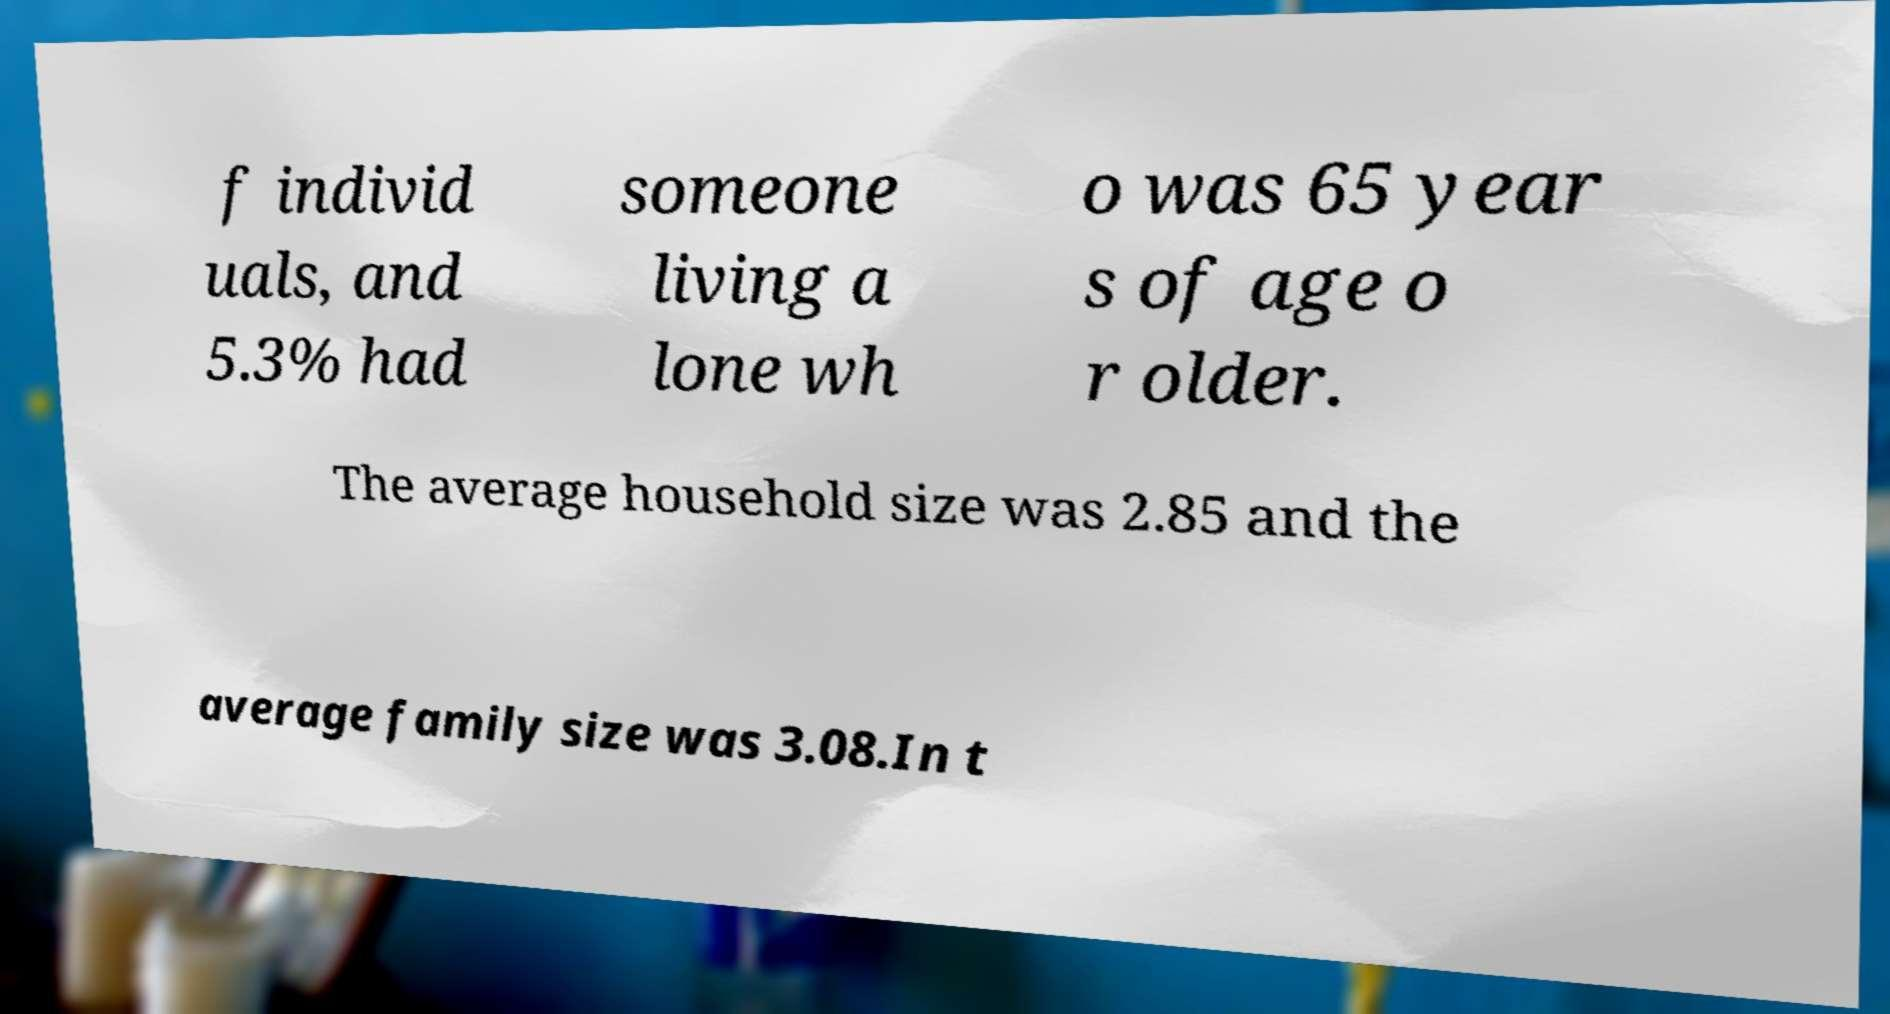There's text embedded in this image that I need extracted. Can you transcribe it verbatim? f individ uals, and 5.3% had someone living a lone wh o was 65 year s of age o r older. The average household size was 2.85 and the average family size was 3.08.In t 